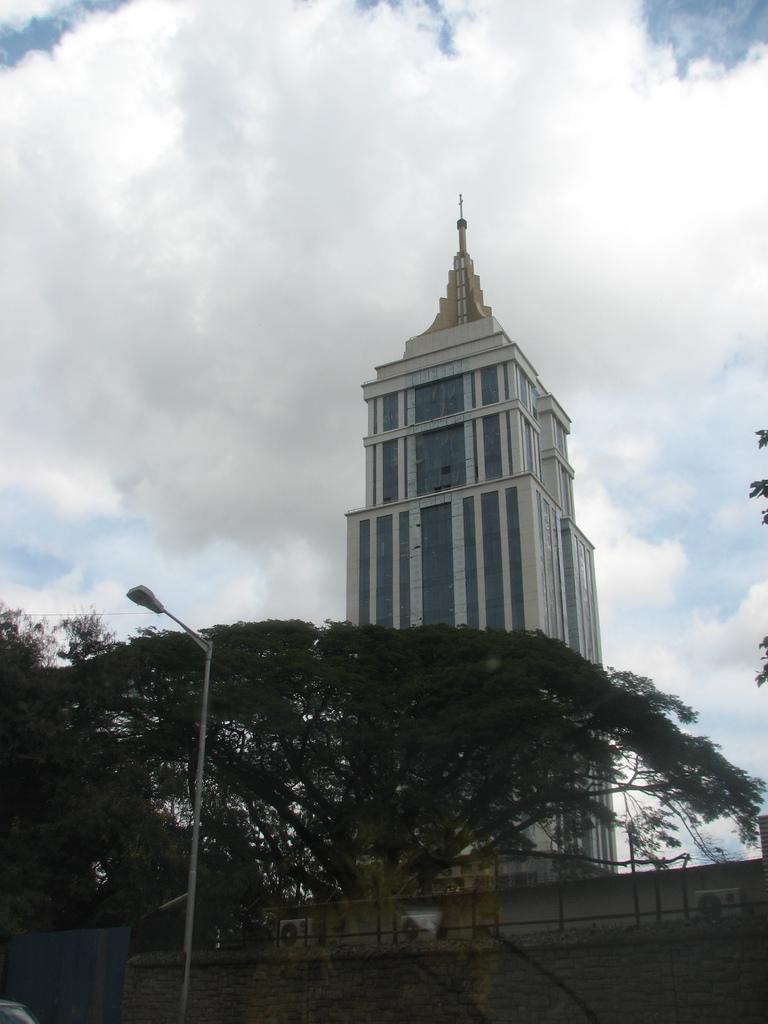What is located on the left side of the image? There is a street light on the left side of the image. What can be seen in the background of the image? There is a wall, trees, an air conditioner, and a tower in the background of the image. What is visible at the top of the image? The sky is visible at the top of the image. How many balls are being juggled by the fan in the image? There is no fan or balls present in the image. What type of tub is visible in the image? There is no tub present in the image. 